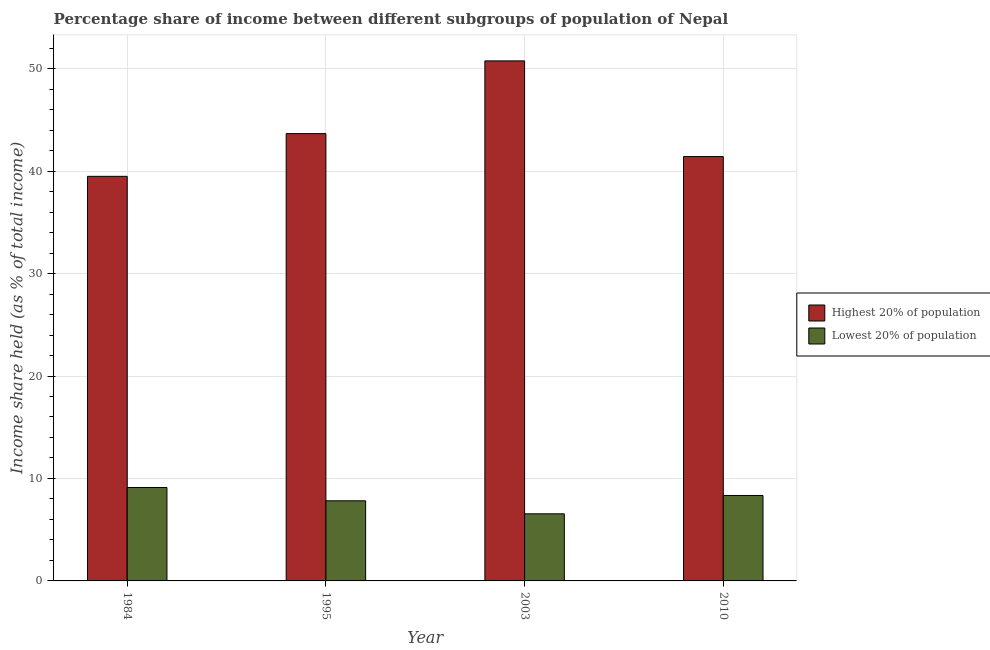How many different coloured bars are there?
Provide a succinct answer. 2. How many groups of bars are there?
Provide a short and direct response. 4. Are the number of bars per tick equal to the number of legend labels?
Provide a succinct answer. Yes. Are the number of bars on each tick of the X-axis equal?
Ensure brevity in your answer.  Yes. How many bars are there on the 3rd tick from the left?
Give a very brief answer. 2. What is the income share held by lowest 20% of the population in 1995?
Keep it short and to the point. 7.82. Across all years, what is the maximum income share held by lowest 20% of the population?
Provide a short and direct response. 9.12. Across all years, what is the minimum income share held by highest 20% of the population?
Your answer should be compact. 39.49. In which year was the income share held by lowest 20% of the population maximum?
Provide a succinct answer. 1984. What is the total income share held by lowest 20% of the population in the graph?
Your answer should be compact. 31.83. What is the difference between the income share held by lowest 20% of the population in 1984 and that in 1995?
Provide a succinct answer. 1.3. What is the difference between the income share held by highest 20% of the population in 2010 and the income share held by lowest 20% of the population in 2003?
Offer a very short reply. -9.34. What is the average income share held by highest 20% of the population per year?
Ensure brevity in your answer.  43.83. In the year 1984, what is the difference between the income share held by highest 20% of the population and income share held by lowest 20% of the population?
Your answer should be compact. 0. In how many years, is the income share held by lowest 20% of the population greater than 40 %?
Your answer should be very brief. 0. What is the ratio of the income share held by lowest 20% of the population in 1984 to that in 2010?
Your answer should be compact. 1.09. Is the income share held by highest 20% of the population in 1984 less than that in 1995?
Provide a succinct answer. Yes. What is the difference between the highest and the second highest income share held by lowest 20% of the population?
Offer a terse response. 0.78. What is the difference between the highest and the lowest income share held by highest 20% of the population?
Keep it short and to the point. 11.27. Is the sum of the income share held by lowest 20% of the population in 2003 and 2010 greater than the maximum income share held by highest 20% of the population across all years?
Ensure brevity in your answer.  Yes. What does the 2nd bar from the left in 1984 represents?
Provide a succinct answer. Lowest 20% of population. What does the 1st bar from the right in 1984 represents?
Make the answer very short. Lowest 20% of population. How many years are there in the graph?
Offer a very short reply. 4. What is the difference between two consecutive major ticks on the Y-axis?
Keep it short and to the point. 10. Are the values on the major ticks of Y-axis written in scientific E-notation?
Your answer should be very brief. No. Does the graph contain grids?
Your response must be concise. Yes. Where does the legend appear in the graph?
Offer a very short reply. Center right. How many legend labels are there?
Ensure brevity in your answer.  2. What is the title of the graph?
Your answer should be very brief. Percentage share of income between different subgroups of population of Nepal. What is the label or title of the X-axis?
Make the answer very short. Year. What is the label or title of the Y-axis?
Offer a terse response. Income share held (as % of total income). What is the Income share held (as % of total income) in Highest 20% of population in 1984?
Your response must be concise. 39.49. What is the Income share held (as % of total income) of Lowest 20% of population in 1984?
Keep it short and to the point. 9.12. What is the Income share held (as % of total income) in Highest 20% of population in 1995?
Your answer should be very brief. 43.66. What is the Income share held (as % of total income) in Lowest 20% of population in 1995?
Your answer should be very brief. 7.82. What is the Income share held (as % of total income) in Highest 20% of population in 2003?
Offer a terse response. 50.76. What is the Income share held (as % of total income) in Lowest 20% of population in 2003?
Your answer should be very brief. 6.55. What is the Income share held (as % of total income) in Highest 20% of population in 2010?
Keep it short and to the point. 41.42. What is the Income share held (as % of total income) in Lowest 20% of population in 2010?
Keep it short and to the point. 8.34. Across all years, what is the maximum Income share held (as % of total income) in Highest 20% of population?
Provide a succinct answer. 50.76. Across all years, what is the maximum Income share held (as % of total income) of Lowest 20% of population?
Offer a very short reply. 9.12. Across all years, what is the minimum Income share held (as % of total income) in Highest 20% of population?
Keep it short and to the point. 39.49. Across all years, what is the minimum Income share held (as % of total income) of Lowest 20% of population?
Keep it short and to the point. 6.55. What is the total Income share held (as % of total income) of Highest 20% of population in the graph?
Your response must be concise. 175.33. What is the total Income share held (as % of total income) of Lowest 20% of population in the graph?
Keep it short and to the point. 31.83. What is the difference between the Income share held (as % of total income) of Highest 20% of population in 1984 and that in 1995?
Give a very brief answer. -4.17. What is the difference between the Income share held (as % of total income) of Highest 20% of population in 1984 and that in 2003?
Ensure brevity in your answer.  -11.27. What is the difference between the Income share held (as % of total income) of Lowest 20% of population in 1984 and that in 2003?
Provide a short and direct response. 2.57. What is the difference between the Income share held (as % of total income) of Highest 20% of population in 1984 and that in 2010?
Provide a short and direct response. -1.93. What is the difference between the Income share held (as % of total income) of Lowest 20% of population in 1984 and that in 2010?
Your answer should be compact. 0.78. What is the difference between the Income share held (as % of total income) of Lowest 20% of population in 1995 and that in 2003?
Your answer should be compact. 1.27. What is the difference between the Income share held (as % of total income) in Highest 20% of population in 1995 and that in 2010?
Your answer should be compact. 2.24. What is the difference between the Income share held (as % of total income) in Lowest 20% of population in 1995 and that in 2010?
Ensure brevity in your answer.  -0.52. What is the difference between the Income share held (as % of total income) of Highest 20% of population in 2003 and that in 2010?
Your answer should be compact. 9.34. What is the difference between the Income share held (as % of total income) in Lowest 20% of population in 2003 and that in 2010?
Offer a terse response. -1.79. What is the difference between the Income share held (as % of total income) in Highest 20% of population in 1984 and the Income share held (as % of total income) in Lowest 20% of population in 1995?
Your response must be concise. 31.67. What is the difference between the Income share held (as % of total income) of Highest 20% of population in 1984 and the Income share held (as % of total income) of Lowest 20% of population in 2003?
Provide a short and direct response. 32.94. What is the difference between the Income share held (as % of total income) in Highest 20% of population in 1984 and the Income share held (as % of total income) in Lowest 20% of population in 2010?
Your answer should be very brief. 31.15. What is the difference between the Income share held (as % of total income) in Highest 20% of population in 1995 and the Income share held (as % of total income) in Lowest 20% of population in 2003?
Make the answer very short. 37.11. What is the difference between the Income share held (as % of total income) in Highest 20% of population in 1995 and the Income share held (as % of total income) in Lowest 20% of population in 2010?
Offer a very short reply. 35.32. What is the difference between the Income share held (as % of total income) in Highest 20% of population in 2003 and the Income share held (as % of total income) in Lowest 20% of population in 2010?
Offer a very short reply. 42.42. What is the average Income share held (as % of total income) of Highest 20% of population per year?
Your answer should be very brief. 43.83. What is the average Income share held (as % of total income) in Lowest 20% of population per year?
Ensure brevity in your answer.  7.96. In the year 1984, what is the difference between the Income share held (as % of total income) of Highest 20% of population and Income share held (as % of total income) of Lowest 20% of population?
Provide a short and direct response. 30.37. In the year 1995, what is the difference between the Income share held (as % of total income) of Highest 20% of population and Income share held (as % of total income) of Lowest 20% of population?
Ensure brevity in your answer.  35.84. In the year 2003, what is the difference between the Income share held (as % of total income) of Highest 20% of population and Income share held (as % of total income) of Lowest 20% of population?
Keep it short and to the point. 44.21. In the year 2010, what is the difference between the Income share held (as % of total income) in Highest 20% of population and Income share held (as % of total income) in Lowest 20% of population?
Make the answer very short. 33.08. What is the ratio of the Income share held (as % of total income) of Highest 20% of population in 1984 to that in 1995?
Ensure brevity in your answer.  0.9. What is the ratio of the Income share held (as % of total income) of Lowest 20% of population in 1984 to that in 1995?
Your answer should be very brief. 1.17. What is the ratio of the Income share held (as % of total income) of Highest 20% of population in 1984 to that in 2003?
Offer a very short reply. 0.78. What is the ratio of the Income share held (as % of total income) of Lowest 20% of population in 1984 to that in 2003?
Provide a succinct answer. 1.39. What is the ratio of the Income share held (as % of total income) in Highest 20% of population in 1984 to that in 2010?
Make the answer very short. 0.95. What is the ratio of the Income share held (as % of total income) in Lowest 20% of population in 1984 to that in 2010?
Make the answer very short. 1.09. What is the ratio of the Income share held (as % of total income) of Highest 20% of population in 1995 to that in 2003?
Your answer should be compact. 0.86. What is the ratio of the Income share held (as % of total income) of Lowest 20% of population in 1995 to that in 2003?
Provide a short and direct response. 1.19. What is the ratio of the Income share held (as % of total income) in Highest 20% of population in 1995 to that in 2010?
Ensure brevity in your answer.  1.05. What is the ratio of the Income share held (as % of total income) of Lowest 20% of population in 1995 to that in 2010?
Make the answer very short. 0.94. What is the ratio of the Income share held (as % of total income) of Highest 20% of population in 2003 to that in 2010?
Make the answer very short. 1.23. What is the ratio of the Income share held (as % of total income) of Lowest 20% of population in 2003 to that in 2010?
Offer a terse response. 0.79. What is the difference between the highest and the second highest Income share held (as % of total income) in Lowest 20% of population?
Your response must be concise. 0.78. What is the difference between the highest and the lowest Income share held (as % of total income) in Highest 20% of population?
Ensure brevity in your answer.  11.27. What is the difference between the highest and the lowest Income share held (as % of total income) in Lowest 20% of population?
Make the answer very short. 2.57. 